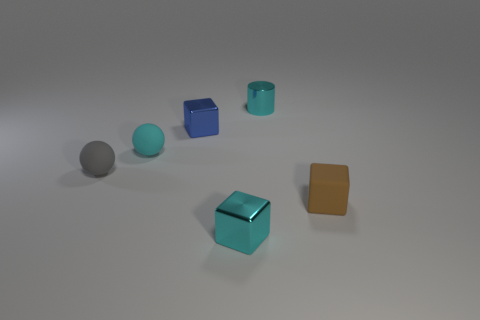Subtract all metallic blocks. How many blocks are left? 1 Add 2 brown spheres. How many objects exist? 8 Subtract 1 blocks. How many blocks are left? 2 Subtract all cylinders. How many objects are left? 5 Add 1 large rubber blocks. How many large rubber blocks exist? 1 Subtract 0 red cylinders. How many objects are left? 6 Subtract all green cubes. Subtract all red balls. How many cubes are left? 3 Subtract all tiny shiny blocks. Subtract all cubes. How many objects are left? 1 Add 4 tiny metal cubes. How many tiny metal cubes are left? 6 